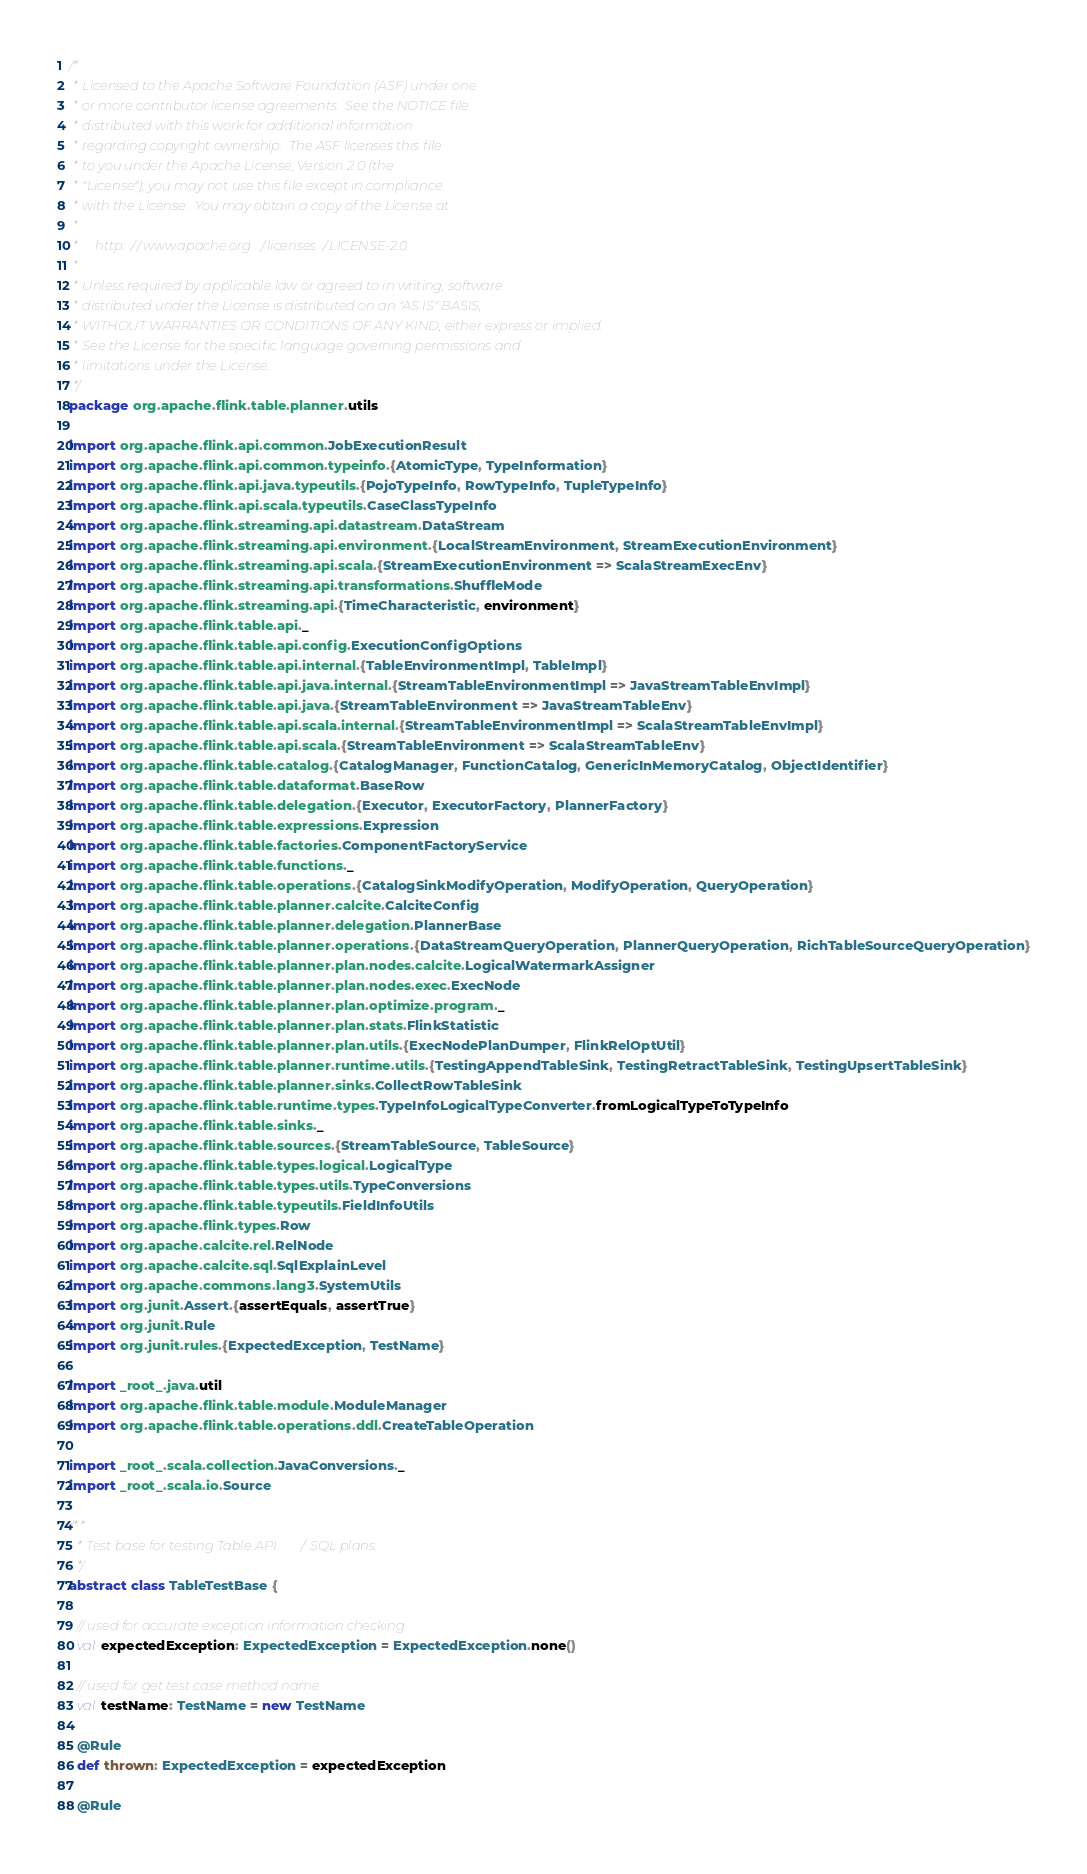Convert code to text. <code><loc_0><loc_0><loc_500><loc_500><_Scala_>/*
 * Licensed to the Apache Software Foundation (ASF) under one
 * or more contributor license agreements.  See the NOTICE file
 * distributed with this work for additional information
 * regarding copyright ownership.  The ASF licenses this file
 * to you under the Apache License, Version 2.0 (the
 * "License"); you may not use this file except in compliance
 * with the License.  You may obtain a copy of the License at
 *
 *     http://www.apache.org/licenses/LICENSE-2.0
 *
 * Unless required by applicable law or agreed to in writing, software
 * distributed under the License is distributed on an "AS IS" BASIS,
 * WITHOUT WARRANTIES OR CONDITIONS OF ANY KIND, either express or implied.
 * See the License for the specific language governing permissions and
 * limitations under the License.
 */
package org.apache.flink.table.planner.utils

import org.apache.flink.api.common.JobExecutionResult
import org.apache.flink.api.common.typeinfo.{AtomicType, TypeInformation}
import org.apache.flink.api.java.typeutils.{PojoTypeInfo, RowTypeInfo, TupleTypeInfo}
import org.apache.flink.api.scala.typeutils.CaseClassTypeInfo
import org.apache.flink.streaming.api.datastream.DataStream
import org.apache.flink.streaming.api.environment.{LocalStreamEnvironment, StreamExecutionEnvironment}
import org.apache.flink.streaming.api.scala.{StreamExecutionEnvironment => ScalaStreamExecEnv}
import org.apache.flink.streaming.api.transformations.ShuffleMode
import org.apache.flink.streaming.api.{TimeCharacteristic, environment}
import org.apache.flink.table.api._
import org.apache.flink.table.api.config.ExecutionConfigOptions
import org.apache.flink.table.api.internal.{TableEnvironmentImpl, TableImpl}
import org.apache.flink.table.api.java.internal.{StreamTableEnvironmentImpl => JavaStreamTableEnvImpl}
import org.apache.flink.table.api.java.{StreamTableEnvironment => JavaStreamTableEnv}
import org.apache.flink.table.api.scala.internal.{StreamTableEnvironmentImpl => ScalaStreamTableEnvImpl}
import org.apache.flink.table.api.scala.{StreamTableEnvironment => ScalaStreamTableEnv}
import org.apache.flink.table.catalog.{CatalogManager, FunctionCatalog, GenericInMemoryCatalog, ObjectIdentifier}
import org.apache.flink.table.dataformat.BaseRow
import org.apache.flink.table.delegation.{Executor, ExecutorFactory, PlannerFactory}
import org.apache.flink.table.expressions.Expression
import org.apache.flink.table.factories.ComponentFactoryService
import org.apache.flink.table.functions._
import org.apache.flink.table.operations.{CatalogSinkModifyOperation, ModifyOperation, QueryOperation}
import org.apache.flink.table.planner.calcite.CalciteConfig
import org.apache.flink.table.planner.delegation.PlannerBase
import org.apache.flink.table.planner.operations.{DataStreamQueryOperation, PlannerQueryOperation, RichTableSourceQueryOperation}
import org.apache.flink.table.planner.plan.nodes.calcite.LogicalWatermarkAssigner
import org.apache.flink.table.planner.plan.nodes.exec.ExecNode
import org.apache.flink.table.planner.plan.optimize.program._
import org.apache.flink.table.planner.plan.stats.FlinkStatistic
import org.apache.flink.table.planner.plan.utils.{ExecNodePlanDumper, FlinkRelOptUtil}
import org.apache.flink.table.planner.runtime.utils.{TestingAppendTableSink, TestingRetractTableSink, TestingUpsertTableSink}
import org.apache.flink.table.planner.sinks.CollectRowTableSink
import org.apache.flink.table.runtime.types.TypeInfoLogicalTypeConverter.fromLogicalTypeToTypeInfo
import org.apache.flink.table.sinks._
import org.apache.flink.table.sources.{StreamTableSource, TableSource}
import org.apache.flink.table.types.logical.LogicalType
import org.apache.flink.table.types.utils.TypeConversions
import org.apache.flink.table.typeutils.FieldInfoUtils
import org.apache.flink.types.Row
import org.apache.calcite.rel.RelNode
import org.apache.calcite.sql.SqlExplainLevel
import org.apache.commons.lang3.SystemUtils
import org.junit.Assert.{assertEquals, assertTrue}
import org.junit.Rule
import org.junit.rules.{ExpectedException, TestName}

import _root_.java.util
import org.apache.flink.table.module.ModuleManager
import org.apache.flink.table.operations.ddl.CreateTableOperation

import _root_.scala.collection.JavaConversions._
import _root_.scala.io.Source

/**
  * Test base for testing Table API / SQL plans.
  */
abstract class TableTestBase {

  // used for accurate exception information checking.
  val expectedException: ExpectedException = ExpectedException.none()

  // used for get test case method name
  val testName: TestName = new TestName

  @Rule
  def thrown: ExpectedException = expectedException

  @Rule</code> 